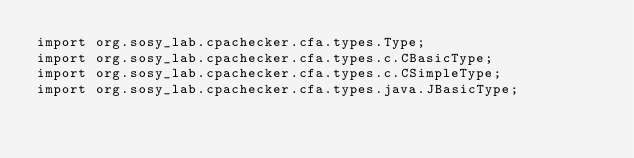Convert code to text. <code><loc_0><loc_0><loc_500><loc_500><_Java_>import org.sosy_lab.cpachecker.cfa.types.Type;
import org.sosy_lab.cpachecker.cfa.types.c.CBasicType;
import org.sosy_lab.cpachecker.cfa.types.c.CSimpleType;
import org.sosy_lab.cpachecker.cfa.types.java.JBasicType;</code> 